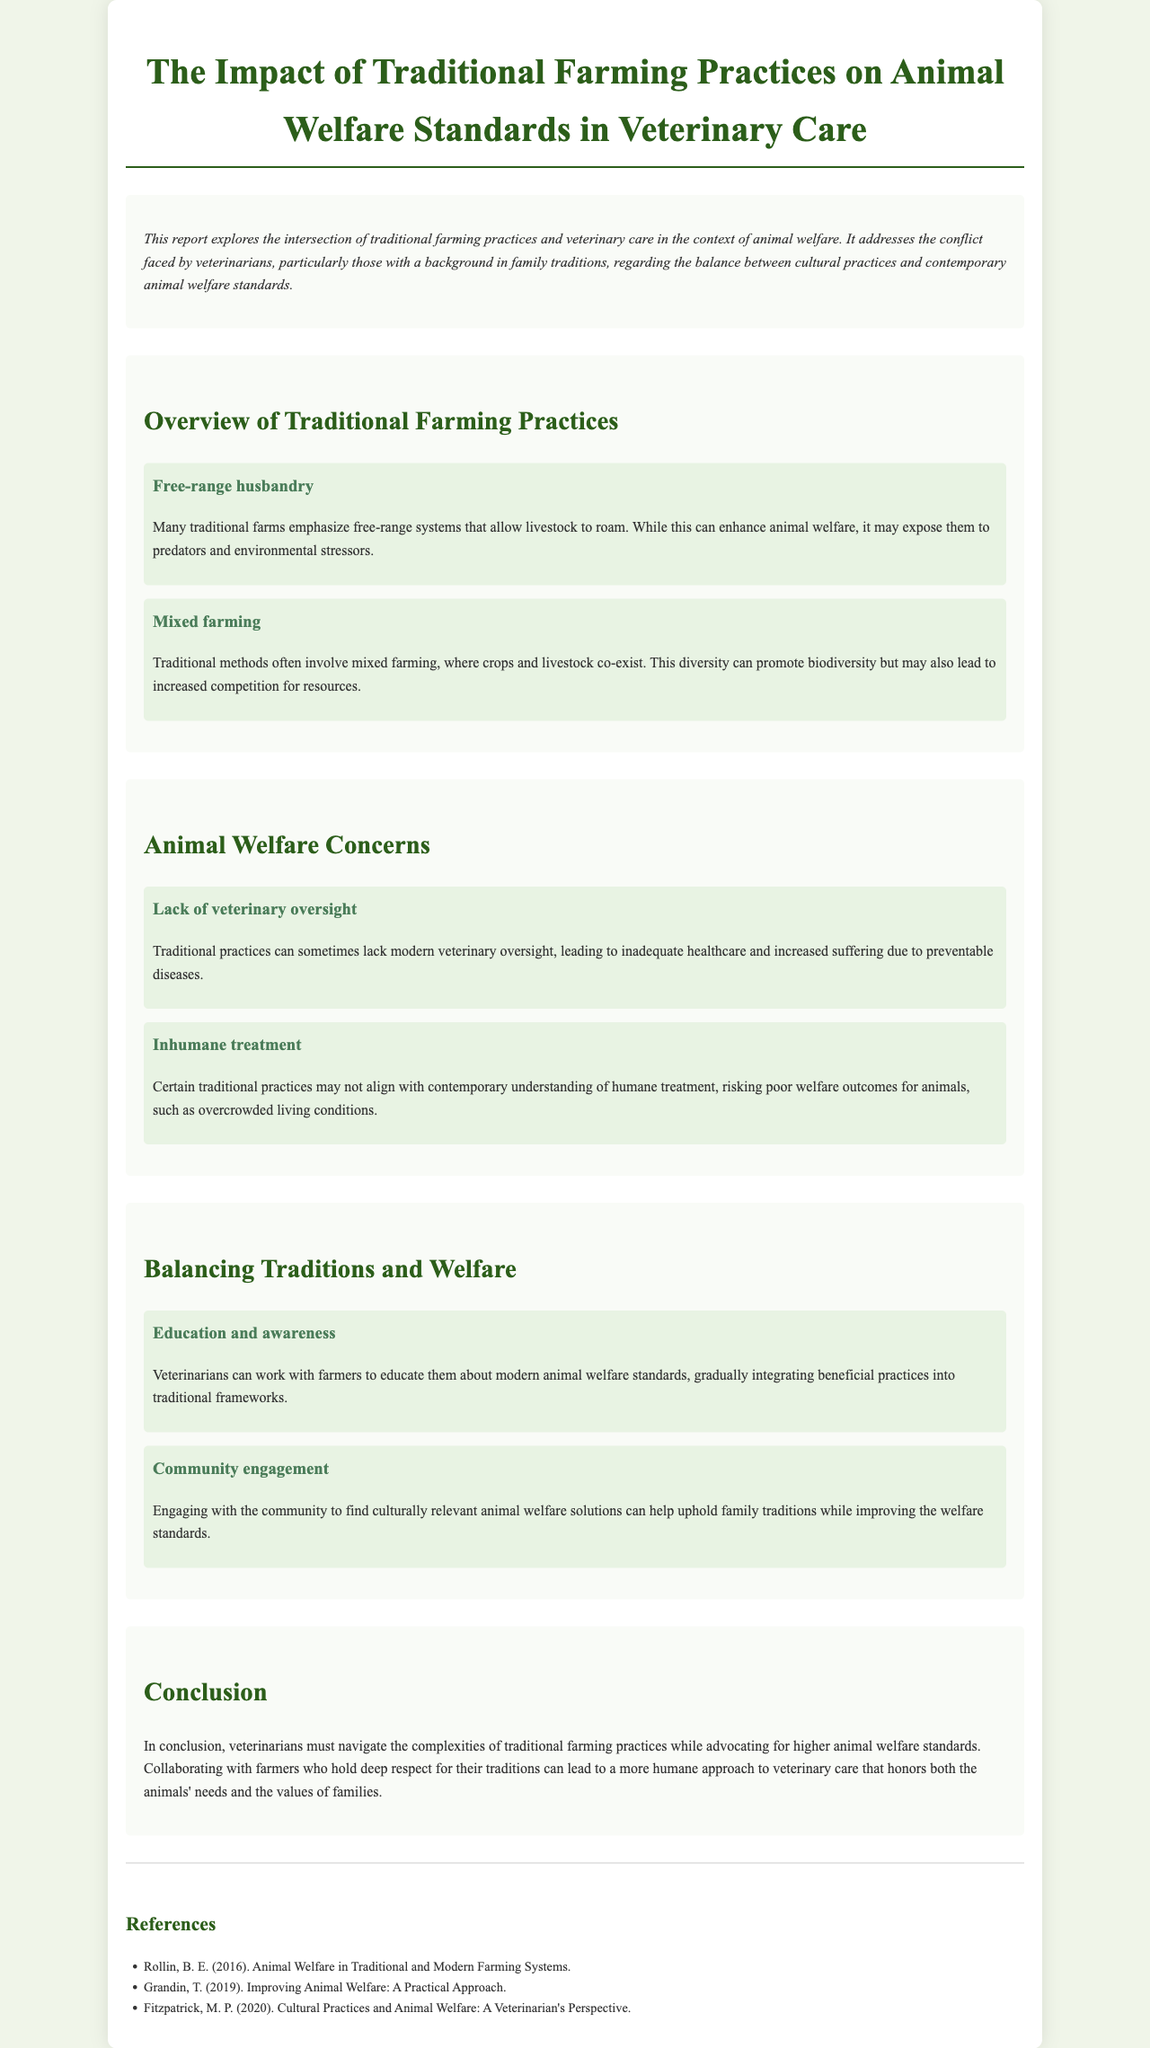What is the title of the report? The title of the report is prominently displayed at the top of the document, summarizing its main focus.
Answer: The Impact of Traditional Farming Practices on Animal Welfare Standards in Veterinary Care What is one practice mentioned in the overview section? One practice in the overview section describes a specific method used in traditional farming.
Answer: Free-range husbandry What is a concern related to animal welfare in traditional practices? The document lists concerns regarding animal welfare as a result of traditional farming practices.
Answer: Lack of veterinary oversight What is one strategy for balancing traditions and welfare? The report suggests approaches to reconcile traditional practices with animal welfare standards.
Answer: Education and awareness How many references are provided at the end of the report? The number of references indicates the sources consulted in supporting the document's claims.
Answer: Three What type of farming is described as co-existing with crops? The document refers to a specific method where both crops and livestock are kept together on the farm.
Answer: Mixed farming What color is used for headings in the document? The document uses a specific color scheme for the headings to enhance visibility and aesthetics.
Answer: Green What key theme is addressed throughout the report? The report aligns its content around a significant theme relevant to the intersection of culture and veterinary care.
Answer: Animal welfare standards 